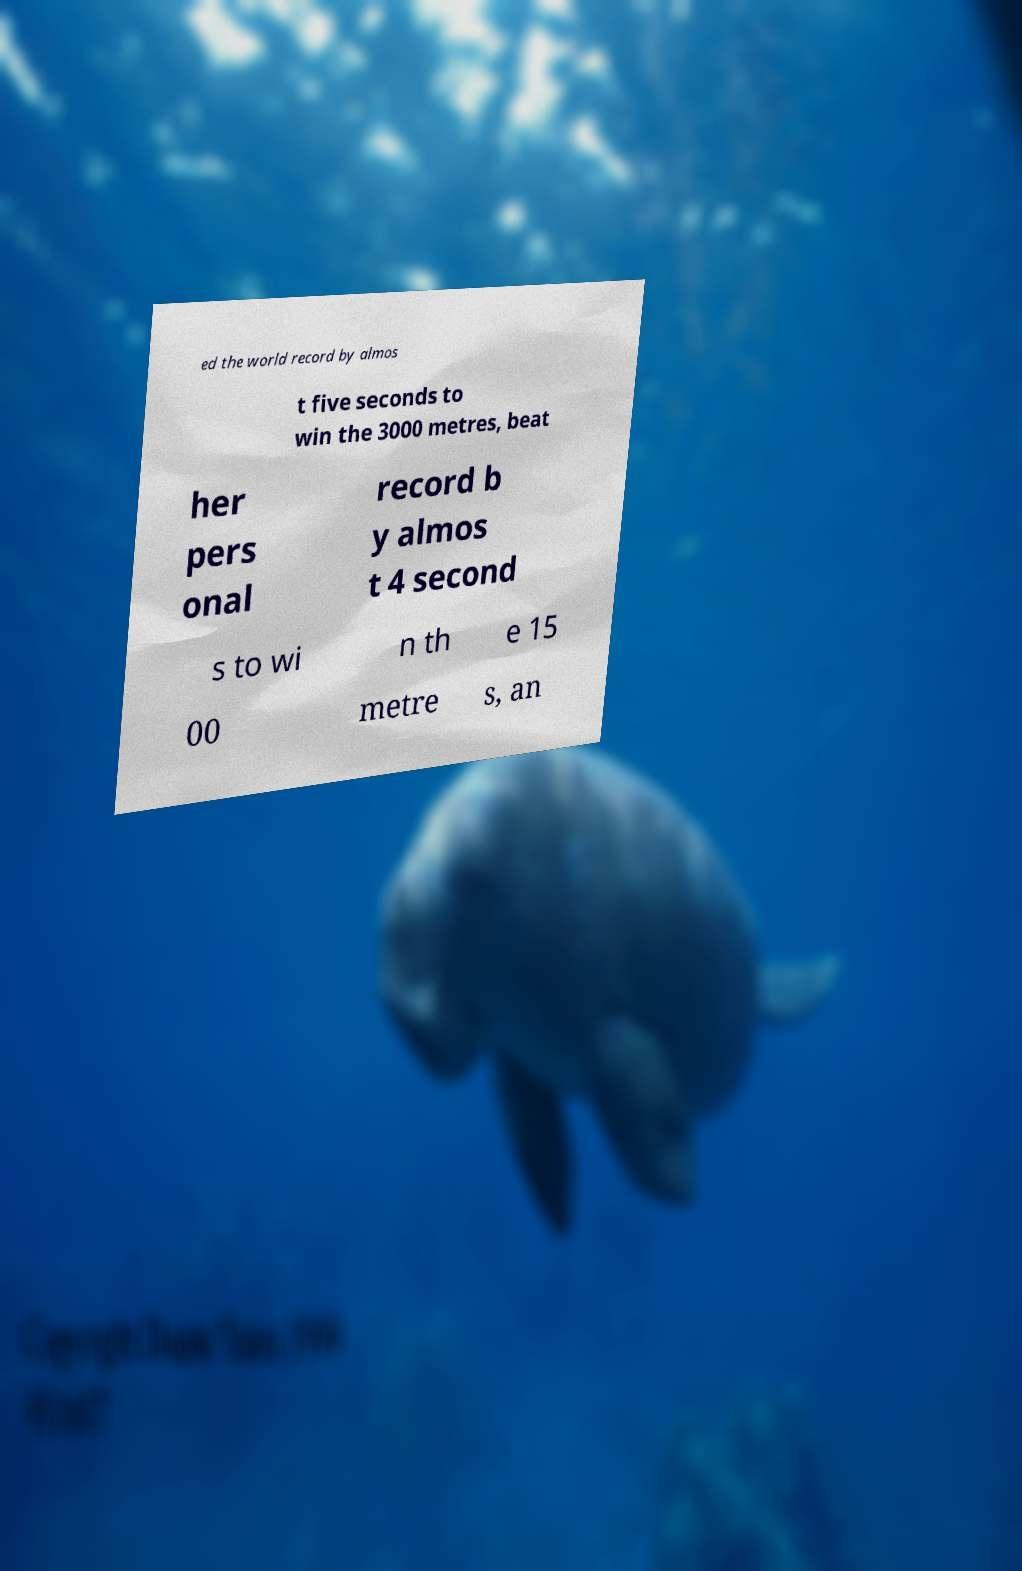Can you accurately transcribe the text from the provided image for me? ed the world record by almos t five seconds to win the 3000 metres, beat her pers onal record b y almos t 4 second s to wi n th e 15 00 metre s, an 